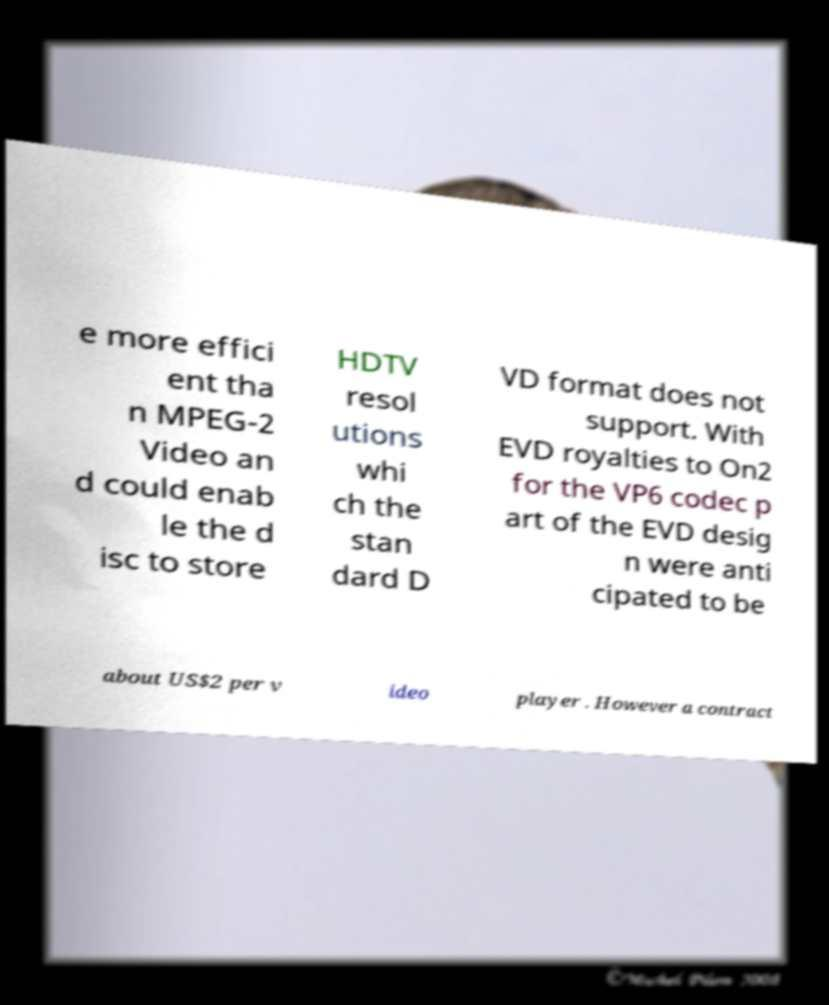Could you extract and type out the text from this image? e more effici ent tha n MPEG-2 Video an d could enab le the d isc to store HDTV resol utions whi ch the stan dard D VD format does not support. With EVD royalties to On2 for the VP6 codec p art of the EVD desig n were anti cipated to be about US$2 per v ideo player . However a contract 